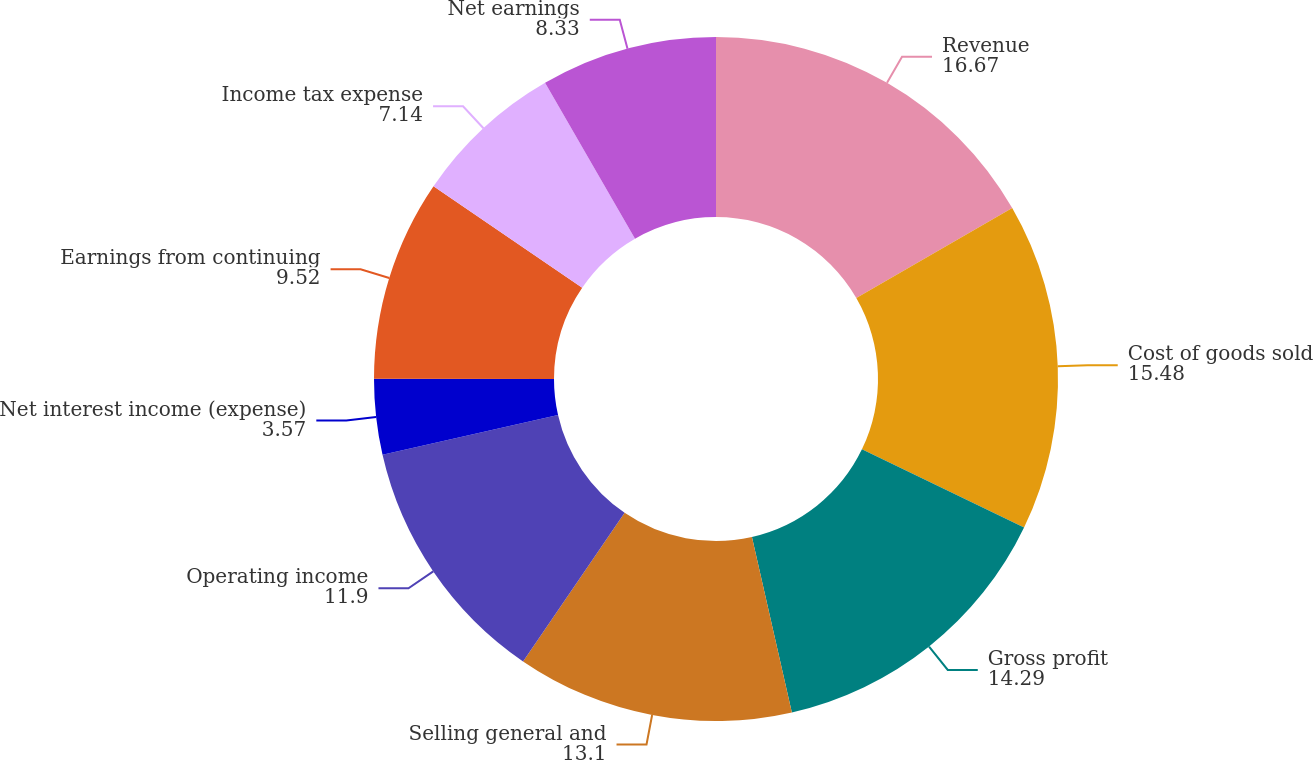Convert chart to OTSL. <chart><loc_0><loc_0><loc_500><loc_500><pie_chart><fcel>Revenue<fcel>Cost of goods sold<fcel>Gross profit<fcel>Selling general and<fcel>Operating income<fcel>Net interest income (expense)<fcel>Earnings from continuing<fcel>Income tax expense<fcel>Net earnings<nl><fcel>16.67%<fcel>15.48%<fcel>14.29%<fcel>13.1%<fcel>11.9%<fcel>3.57%<fcel>9.52%<fcel>7.14%<fcel>8.33%<nl></chart> 